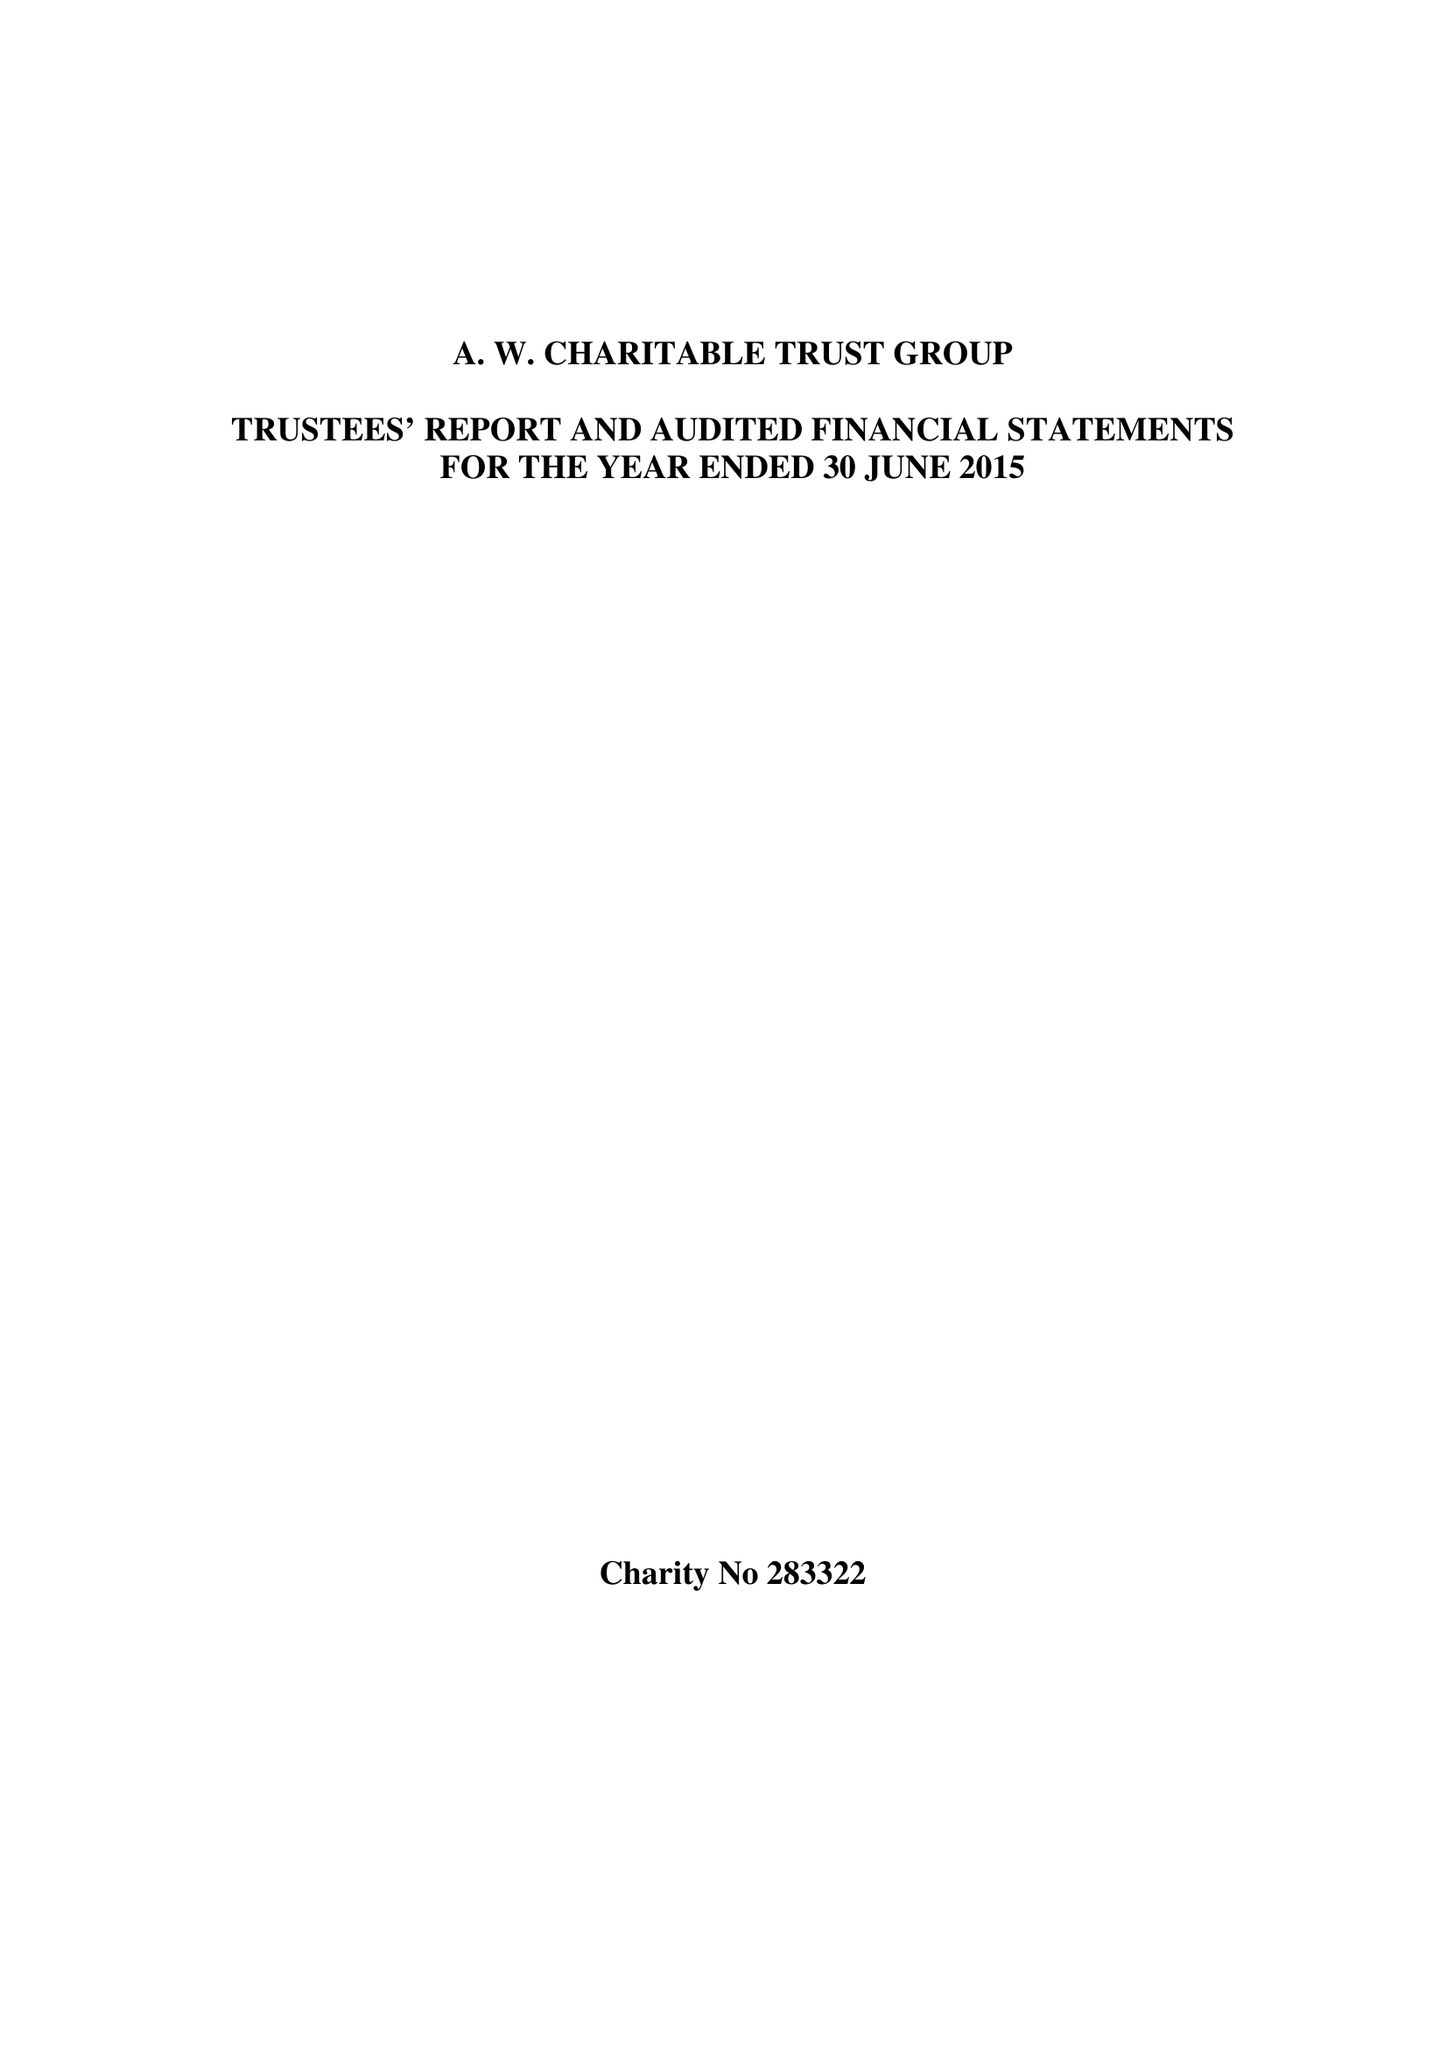What is the value for the spending_annually_in_british_pounds?
Answer the question using a single word or phrase. 5537000.00 